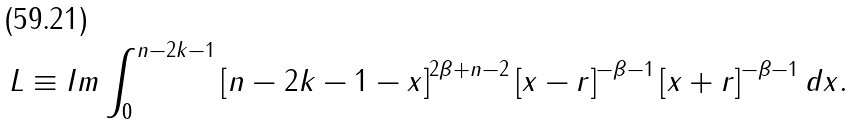<formula> <loc_0><loc_0><loc_500><loc_500>L \equiv I m \int _ { 0 } ^ { n - 2 k - 1 } \left [ n - 2 k - 1 - x \right ] ^ { 2 \beta + n - 2 } \left [ x - r \right ] ^ { - \beta - 1 } \left [ x + r \right ] ^ { - \beta - 1 } d x .</formula> 